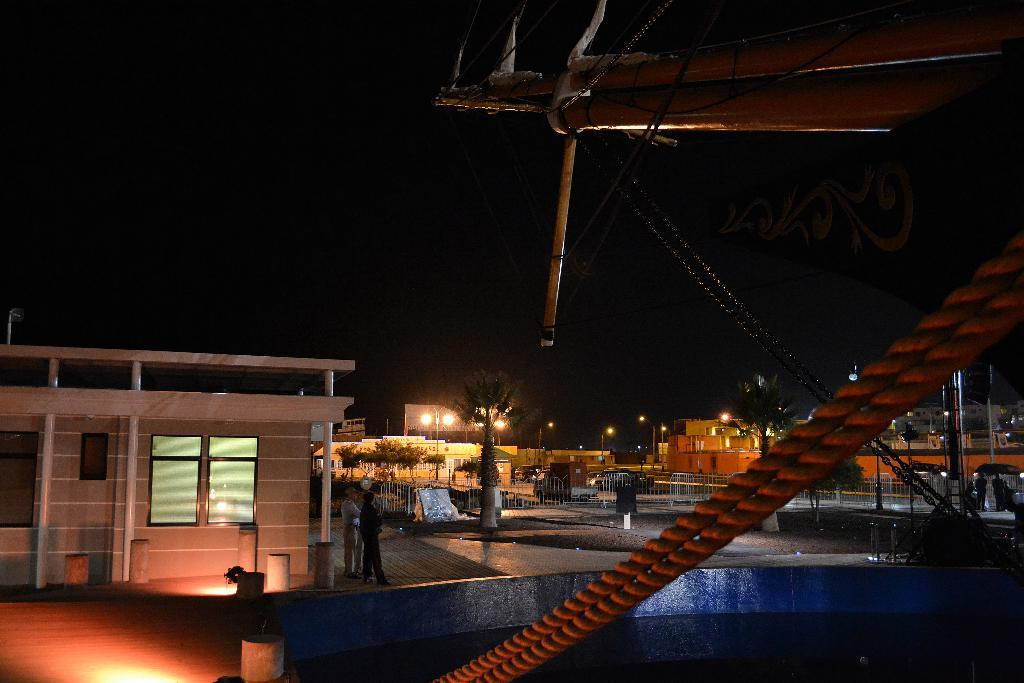What type of machinery can be seen in the image? There is a construction crane in the image. What is on the road in the image? There are grills on the road in the image. What structures are visible in the image? There are buildings in the image. What type of vertical structures are present in the image? Street poles are visible in the image. What type of lighting is present in the image? Street lights are present in the image. What type of people can be seen in the image? There are persons standing on the floor in the image. What type of natural elements are visible in the image? Trees are visible in the image. What part of the natural environment is visible in the image? The sky is visible in the image. What type of gold object can be seen being kicked in the image? There is no gold object or kicking activity present in the image. What type of slope can be seen in the image? There is no slope visible in the image. 